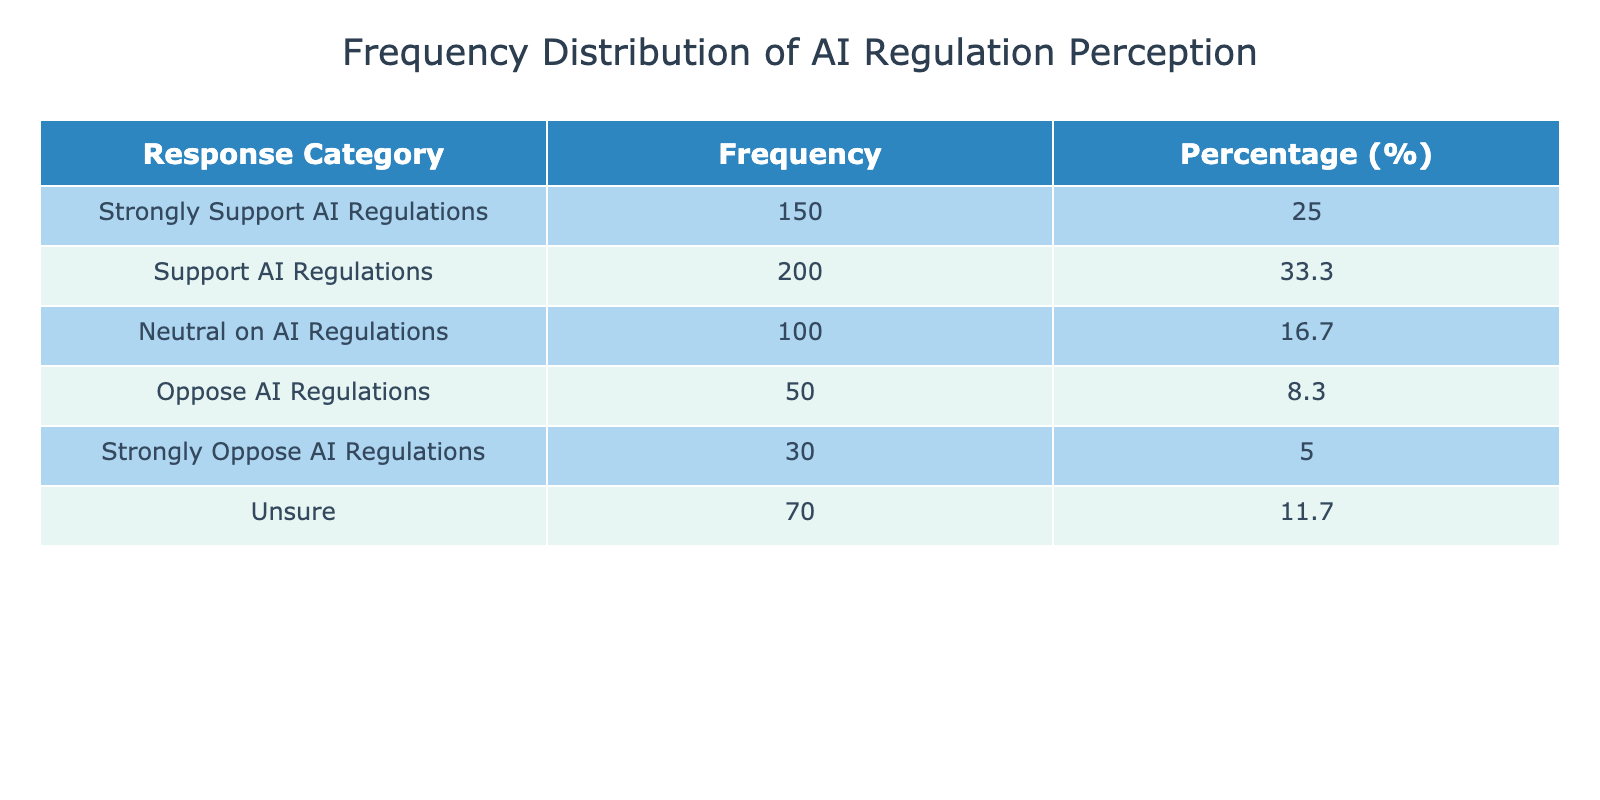What is the frequency of respondents who oppose AI regulations? The table lists "Oppose AI Regulations" with a frequency of 50. Therefore, the answer is taken directly from the table.
Answer: 50 What percentage of respondents strongly support AI regulations? The frequency for "Strongly Support AI Regulations" is 150. The total frequency is 600. To calculate the percentage: (150/600) * 100 = 25.0%. Therefore, the answer is included in the calculated percentage in the table.
Answer: 25.0 How many respondents either support or strongly support AI regulations? The frequencies for "Support AI Regulations" and "Strongly Support AI Regulations" are 200 and 150 respectively. Adding these gives 200 + 150 = 350.
Answer: 350 Is the number of respondents who are neutral on AI regulations higher than those who strongly oppose AI regulations? "Neutral on AI Regulations" has a frequency of 100, while "Strongly Oppose AI Regulations" has a frequency of 30. Since 100 is greater than 30, the answer is yes.
Answer: Yes What is the combined frequency of those who are unsure about AI regulations and those who oppose them? The frequency of "Unsure" is 70 and "Oppose AI Regulations" is 50. Adding these together gives 70 + 50 = 120. Thus, the combined frequency is calculated.
Answer: 120 What percentage of respondents neither support nor oppose AI regulations (considering neutral and unsure)? The frequencies for "Neutral on AI Regulations" and "Unsure" are 100 and 70 respectively. Summing these gives 100 + 70 = 170. The total frequency is 600, so the percentage is (170/600) * 100 = 28.3%. This is accounted and calculated from the provided values.
Answer: 28.3% How many more respondents support AI regulations compared to those who strongly oppose them? The frequency for "Support AI Regulations" is 200 and for "Strongly Oppose AI Regulations" it is 30. The difference is calculated as 200 - 30 = 170, thus providing the count of the difference directly.
Answer: 170 What proportion of respondents are either neutral or support AI regulations? The frequencies for "Neutral on AI Regulations" and "Support AI Regulations" are 100 and 200 respectively. The combined number is 100 + 200 = 300. The total frequency is 600; thus, the proportion is 300/600 = 0.5 or 50%. This proportion is directly derived from the relevant categories.
Answer: 50% 